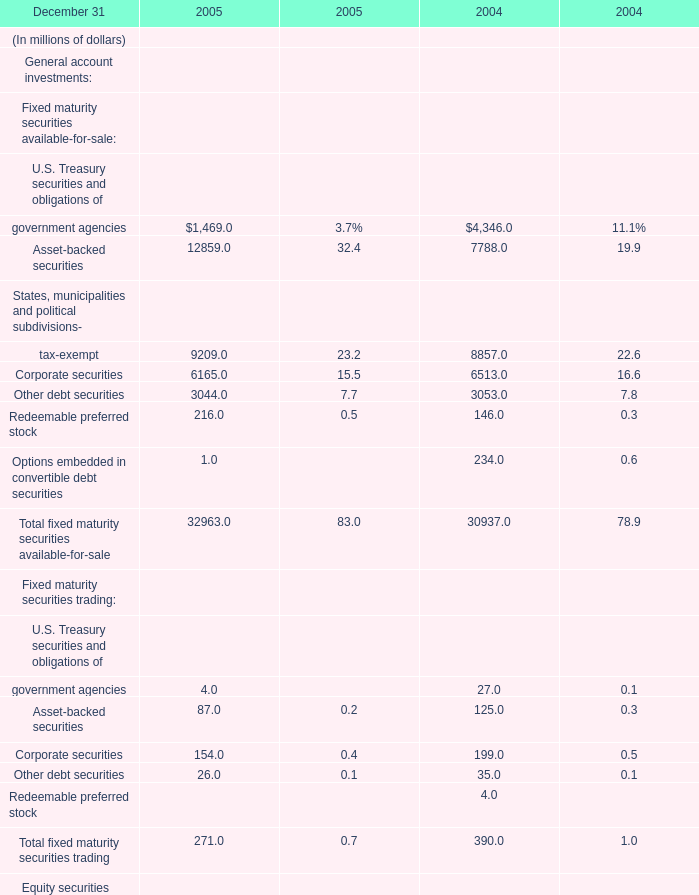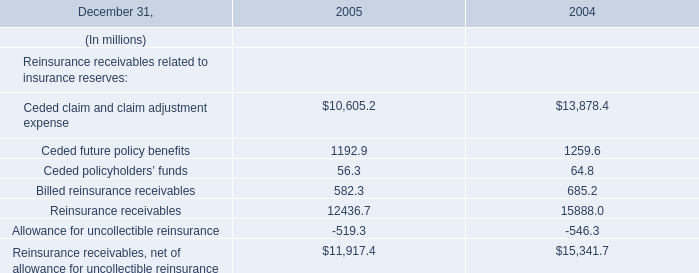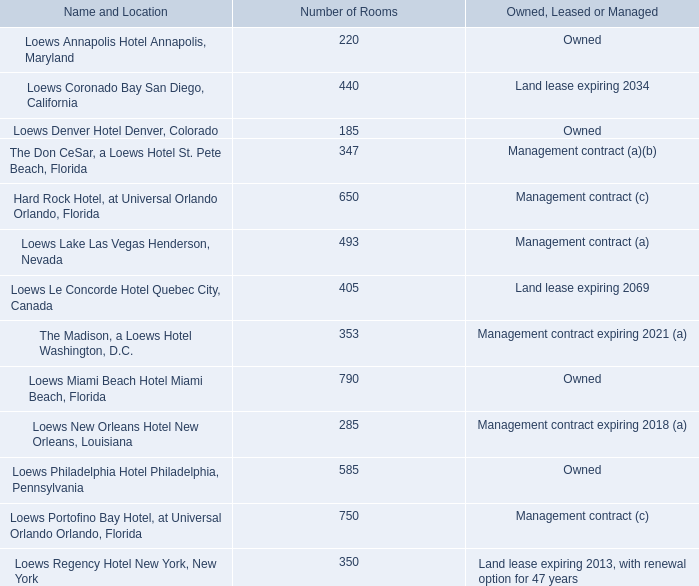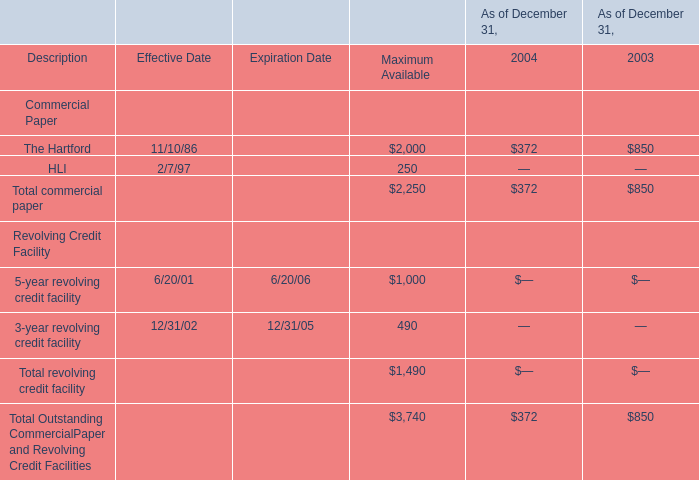What was the total amount of Fixed maturity securities trading excluding those Fixed maturity securities trading greater than 100 in 2005? (in million) 
Computations: ((4.0 + 87.0) + 26.0)
Answer: 117.0. 